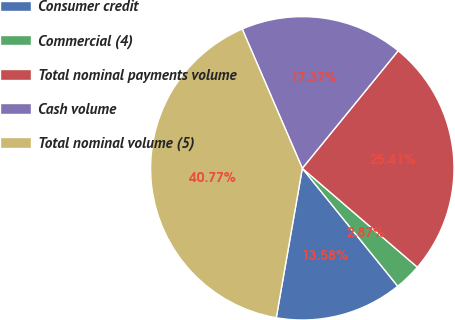Convert chart. <chart><loc_0><loc_0><loc_500><loc_500><pie_chart><fcel>Consumer credit<fcel>Commercial (4)<fcel>Total nominal payments volume<fcel>Cash volume<fcel>Total nominal volume (5)<nl><fcel>13.58%<fcel>2.87%<fcel>25.41%<fcel>17.37%<fcel>40.77%<nl></chart> 